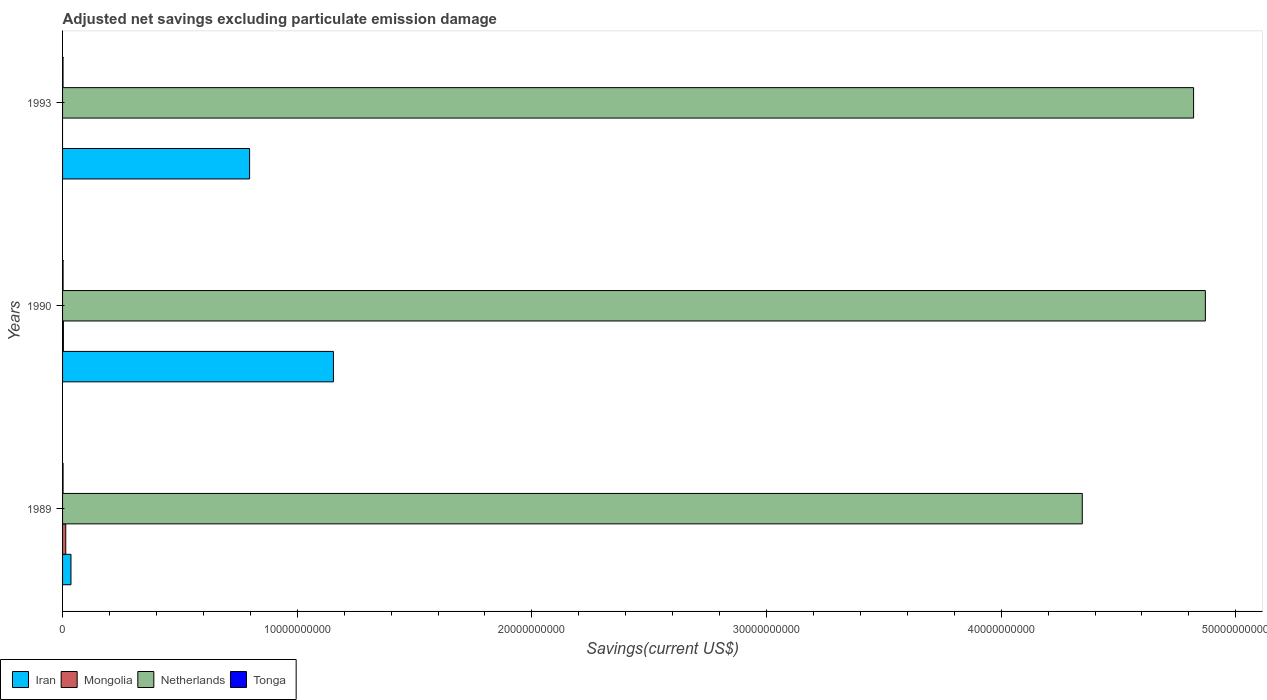What is the label of the 2nd group of bars from the top?
Your response must be concise. 1990. In how many cases, is the number of bars for a given year not equal to the number of legend labels?
Make the answer very short. 1. What is the adjusted net savings in Tonga in 1993?
Your answer should be compact. 2.01e+07. Across all years, what is the maximum adjusted net savings in Mongolia?
Provide a succinct answer. 1.35e+08. Across all years, what is the minimum adjusted net savings in Iran?
Give a very brief answer. 3.58e+08. In which year was the adjusted net savings in Iran maximum?
Your answer should be compact. 1990. What is the total adjusted net savings in Mongolia in the graph?
Provide a short and direct response. 1.71e+08. What is the difference between the adjusted net savings in Netherlands in 1990 and that in 1993?
Your answer should be very brief. 5.01e+08. What is the difference between the adjusted net savings in Tonga in 1990 and the adjusted net savings in Netherlands in 1989?
Your answer should be compact. -4.34e+1. What is the average adjusted net savings in Netherlands per year?
Give a very brief answer. 4.68e+1. In the year 1989, what is the difference between the adjusted net savings in Tonga and adjusted net savings in Mongolia?
Make the answer very short. -1.14e+08. In how many years, is the adjusted net savings in Netherlands greater than 30000000000 US$?
Your answer should be very brief. 3. What is the ratio of the adjusted net savings in Iran in 1989 to that in 1990?
Keep it short and to the point. 0.03. Is the difference between the adjusted net savings in Tonga in 1989 and 1990 greater than the difference between the adjusted net savings in Mongolia in 1989 and 1990?
Your answer should be very brief. No. What is the difference between the highest and the second highest adjusted net savings in Iran?
Keep it short and to the point. 3.57e+09. What is the difference between the highest and the lowest adjusted net savings in Tonga?
Give a very brief answer. 1.53e+06. Is it the case that in every year, the sum of the adjusted net savings in Netherlands and adjusted net savings in Tonga is greater than the sum of adjusted net savings in Mongolia and adjusted net savings in Iran?
Offer a very short reply. Yes. How many bars are there?
Make the answer very short. 11. Are all the bars in the graph horizontal?
Your answer should be compact. Yes. Does the graph contain any zero values?
Keep it short and to the point. Yes. Where does the legend appear in the graph?
Your response must be concise. Bottom left. How many legend labels are there?
Provide a succinct answer. 4. What is the title of the graph?
Your response must be concise. Adjusted net savings excluding particulate emission damage. What is the label or title of the X-axis?
Provide a succinct answer. Savings(current US$). What is the Savings(current US$) in Iran in 1989?
Make the answer very short. 3.58e+08. What is the Savings(current US$) in Mongolia in 1989?
Your answer should be compact. 1.35e+08. What is the Savings(current US$) in Netherlands in 1989?
Ensure brevity in your answer.  4.35e+1. What is the Savings(current US$) of Tonga in 1989?
Ensure brevity in your answer.  2.09e+07. What is the Savings(current US$) of Iran in 1990?
Provide a short and direct response. 1.15e+1. What is the Savings(current US$) of Mongolia in 1990?
Make the answer very short. 3.55e+07. What is the Savings(current US$) in Netherlands in 1990?
Provide a short and direct response. 4.87e+1. What is the Savings(current US$) in Tonga in 1990?
Keep it short and to the point. 2.17e+07. What is the Savings(current US$) of Iran in 1993?
Your response must be concise. 7.97e+09. What is the Savings(current US$) of Mongolia in 1993?
Give a very brief answer. 0. What is the Savings(current US$) of Netherlands in 1993?
Keep it short and to the point. 4.82e+1. What is the Savings(current US$) in Tonga in 1993?
Your response must be concise. 2.01e+07. Across all years, what is the maximum Savings(current US$) of Iran?
Ensure brevity in your answer.  1.15e+1. Across all years, what is the maximum Savings(current US$) of Mongolia?
Your answer should be compact. 1.35e+08. Across all years, what is the maximum Savings(current US$) in Netherlands?
Offer a terse response. 4.87e+1. Across all years, what is the maximum Savings(current US$) in Tonga?
Ensure brevity in your answer.  2.17e+07. Across all years, what is the minimum Savings(current US$) in Iran?
Provide a short and direct response. 3.58e+08. Across all years, what is the minimum Savings(current US$) in Netherlands?
Give a very brief answer. 4.35e+1. Across all years, what is the minimum Savings(current US$) in Tonga?
Offer a very short reply. 2.01e+07. What is the total Savings(current US$) of Iran in the graph?
Your answer should be compact. 1.99e+1. What is the total Savings(current US$) of Mongolia in the graph?
Provide a short and direct response. 1.71e+08. What is the total Savings(current US$) of Netherlands in the graph?
Offer a very short reply. 1.40e+11. What is the total Savings(current US$) of Tonga in the graph?
Ensure brevity in your answer.  6.27e+07. What is the difference between the Savings(current US$) of Iran in 1989 and that in 1990?
Give a very brief answer. -1.12e+1. What is the difference between the Savings(current US$) of Mongolia in 1989 and that in 1990?
Give a very brief answer. 9.99e+07. What is the difference between the Savings(current US$) in Netherlands in 1989 and that in 1990?
Your answer should be very brief. -5.24e+09. What is the difference between the Savings(current US$) of Tonga in 1989 and that in 1990?
Your response must be concise. -7.25e+05. What is the difference between the Savings(current US$) of Iran in 1989 and that in 1993?
Your response must be concise. -7.61e+09. What is the difference between the Savings(current US$) of Netherlands in 1989 and that in 1993?
Provide a short and direct response. -4.74e+09. What is the difference between the Savings(current US$) of Tonga in 1989 and that in 1993?
Make the answer very short. 8.01e+05. What is the difference between the Savings(current US$) in Iran in 1990 and that in 1993?
Keep it short and to the point. 3.57e+09. What is the difference between the Savings(current US$) in Netherlands in 1990 and that in 1993?
Provide a succinct answer. 5.01e+08. What is the difference between the Savings(current US$) of Tonga in 1990 and that in 1993?
Your answer should be very brief. 1.53e+06. What is the difference between the Savings(current US$) in Iran in 1989 and the Savings(current US$) in Mongolia in 1990?
Give a very brief answer. 3.22e+08. What is the difference between the Savings(current US$) in Iran in 1989 and the Savings(current US$) in Netherlands in 1990?
Give a very brief answer. -4.83e+1. What is the difference between the Savings(current US$) in Iran in 1989 and the Savings(current US$) in Tonga in 1990?
Your answer should be compact. 3.36e+08. What is the difference between the Savings(current US$) in Mongolia in 1989 and the Savings(current US$) in Netherlands in 1990?
Provide a succinct answer. -4.86e+1. What is the difference between the Savings(current US$) of Mongolia in 1989 and the Savings(current US$) of Tonga in 1990?
Offer a terse response. 1.14e+08. What is the difference between the Savings(current US$) in Netherlands in 1989 and the Savings(current US$) in Tonga in 1990?
Your answer should be compact. 4.34e+1. What is the difference between the Savings(current US$) of Iran in 1989 and the Savings(current US$) of Netherlands in 1993?
Your response must be concise. -4.78e+1. What is the difference between the Savings(current US$) in Iran in 1989 and the Savings(current US$) in Tonga in 1993?
Your answer should be compact. 3.38e+08. What is the difference between the Savings(current US$) of Mongolia in 1989 and the Savings(current US$) of Netherlands in 1993?
Offer a terse response. -4.81e+1. What is the difference between the Savings(current US$) in Mongolia in 1989 and the Savings(current US$) in Tonga in 1993?
Your answer should be compact. 1.15e+08. What is the difference between the Savings(current US$) of Netherlands in 1989 and the Savings(current US$) of Tonga in 1993?
Keep it short and to the point. 4.34e+1. What is the difference between the Savings(current US$) in Iran in 1990 and the Savings(current US$) in Netherlands in 1993?
Your response must be concise. -3.67e+1. What is the difference between the Savings(current US$) of Iran in 1990 and the Savings(current US$) of Tonga in 1993?
Make the answer very short. 1.15e+1. What is the difference between the Savings(current US$) in Mongolia in 1990 and the Savings(current US$) in Netherlands in 1993?
Ensure brevity in your answer.  -4.82e+1. What is the difference between the Savings(current US$) in Mongolia in 1990 and the Savings(current US$) in Tonga in 1993?
Provide a succinct answer. 1.54e+07. What is the difference between the Savings(current US$) in Netherlands in 1990 and the Savings(current US$) in Tonga in 1993?
Offer a very short reply. 4.87e+1. What is the average Savings(current US$) in Iran per year?
Provide a short and direct response. 6.62e+09. What is the average Savings(current US$) of Mongolia per year?
Make the answer very short. 5.70e+07. What is the average Savings(current US$) of Netherlands per year?
Offer a terse response. 4.68e+1. What is the average Savings(current US$) of Tonga per year?
Make the answer very short. 2.09e+07. In the year 1989, what is the difference between the Savings(current US$) of Iran and Savings(current US$) of Mongolia?
Provide a succinct answer. 2.22e+08. In the year 1989, what is the difference between the Savings(current US$) in Iran and Savings(current US$) in Netherlands?
Your response must be concise. -4.31e+1. In the year 1989, what is the difference between the Savings(current US$) in Iran and Savings(current US$) in Tonga?
Make the answer very short. 3.37e+08. In the year 1989, what is the difference between the Savings(current US$) in Mongolia and Savings(current US$) in Netherlands?
Provide a succinct answer. -4.33e+1. In the year 1989, what is the difference between the Savings(current US$) in Mongolia and Savings(current US$) in Tonga?
Your answer should be very brief. 1.14e+08. In the year 1989, what is the difference between the Savings(current US$) in Netherlands and Savings(current US$) in Tonga?
Ensure brevity in your answer.  4.34e+1. In the year 1990, what is the difference between the Savings(current US$) of Iran and Savings(current US$) of Mongolia?
Your answer should be very brief. 1.15e+1. In the year 1990, what is the difference between the Savings(current US$) in Iran and Savings(current US$) in Netherlands?
Your response must be concise. -3.72e+1. In the year 1990, what is the difference between the Savings(current US$) of Iran and Savings(current US$) of Tonga?
Make the answer very short. 1.15e+1. In the year 1990, what is the difference between the Savings(current US$) of Mongolia and Savings(current US$) of Netherlands?
Your answer should be very brief. -4.87e+1. In the year 1990, what is the difference between the Savings(current US$) of Mongolia and Savings(current US$) of Tonga?
Offer a terse response. 1.38e+07. In the year 1990, what is the difference between the Savings(current US$) of Netherlands and Savings(current US$) of Tonga?
Your answer should be very brief. 4.87e+1. In the year 1993, what is the difference between the Savings(current US$) in Iran and Savings(current US$) in Netherlands?
Ensure brevity in your answer.  -4.02e+1. In the year 1993, what is the difference between the Savings(current US$) in Iran and Savings(current US$) in Tonga?
Your response must be concise. 7.95e+09. In the year 1993, what is the difference between the Savings(current US$) in Netherlands and Savings(current US$) in Tonga?
Ensure brevity in your answer.  4.82e+1. What is the ratio of the Savings(current US$) of Iran in 1989 to that in 1990?
Your answer should be compact. 0.03. What is the ratio of the Savings(current US$) of Mongolia in 1989 to that in 1990?
Ensure brevity in your answer.  3.81. What is the ratio of the Savings(current US$) of Netherlands in 1989 to that in 1990?
Give a very brief answer. 0.89. What is the ratio of the Savings(current US$) in Tonga in 1989 to that in 1990?
Your response must be concise. 0.97. What is the ratio of the Savings(current US$) of Iran in 1989 to that in 1993?
Your answer should be very brief. 0.04. What is the ratio of the Savings(current US$) of Netherlands in 1989 to that in 1993?
Make the answer very short. 0.9. What is the ratio of the Savings(current US$) in Tonga in 1989 to that in 1993?
Keep it short and to the point. 1.04. What is the ratio of the Savings(current US$) of Iran in 1990 to that in 1993?
Keep it short and to the point. 1.45. What is the ratio of the Savings(current US$) in Netherlands in 1990 to that in 1993?
Offer a very short reply. 1.01. What is the ratio of the Savings(current US$) in Tonga in 1990 to that in 1993?
Make the answer very short. 1.08. What is the difference between the highest and the second highest Savings(current US$) in Iran?
Your answer should be very brief. 3.57e+09. What is the difference between the highest and the second highest Savings(current US$) of Netherlands?
Ensure brevity in your answer.  5.01e+08. What is the difference between the highest and the second highest Savings(current US$) of Tonga?
Offer a terse response. 7.25e+05. What is the difference between the highest and the lowest Savings(current US$) of Iran?
Provide a succinct answer. 1.12e+1. What is the difference between the highest and the lowest Savings(current US$) in Mongolia?
Your answer should be very brief. 1.35e+08. What is the difference between the highest and the lowest Savings(current US$) in Netherlands?
Offer a very short reply. 5.24e+09. What is the difference between the highest and the lowest Savings(current US$) in Tonga?
Offer a terse response. 1.53e+06. 